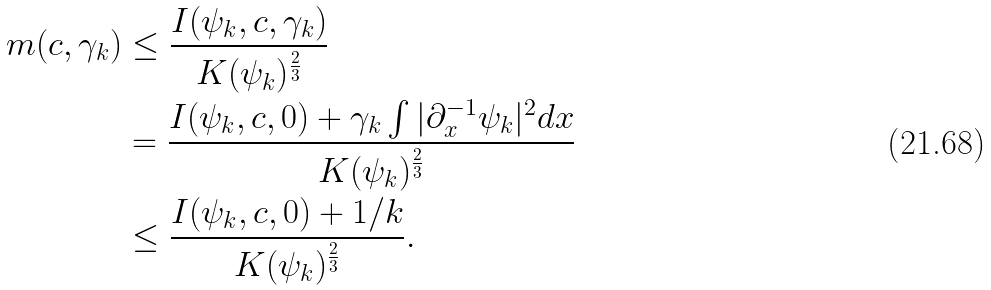Convert formula to latex. <formula><loc_0><loc_0><loc_500><loc_500>m ( c , \gamma _ { k } ) & \leq \frac { I ( \psi _ { k } , c , \gamma _ { k } ) } { K ( \psi _ { k } ) ^ { \frac { 2 } { 3 } } } \\ & = \frac { I ( \psi _ { k } , c , 0 ) + \gamma _ { k } \int | \partial _ { x } ^ { - 1 } \psi _ { k } | ^ { 2 } d x } { K ( \psi _ { k } ) ^ { \frac { 2 } { 3 } } } \\ & \leq \frac { I ( \psi _ { k } , c , 0 ) + 1 / k } { K ( \psi _ { k } ) ^ { \frac { 2 } { 3 } } } .</formula> 